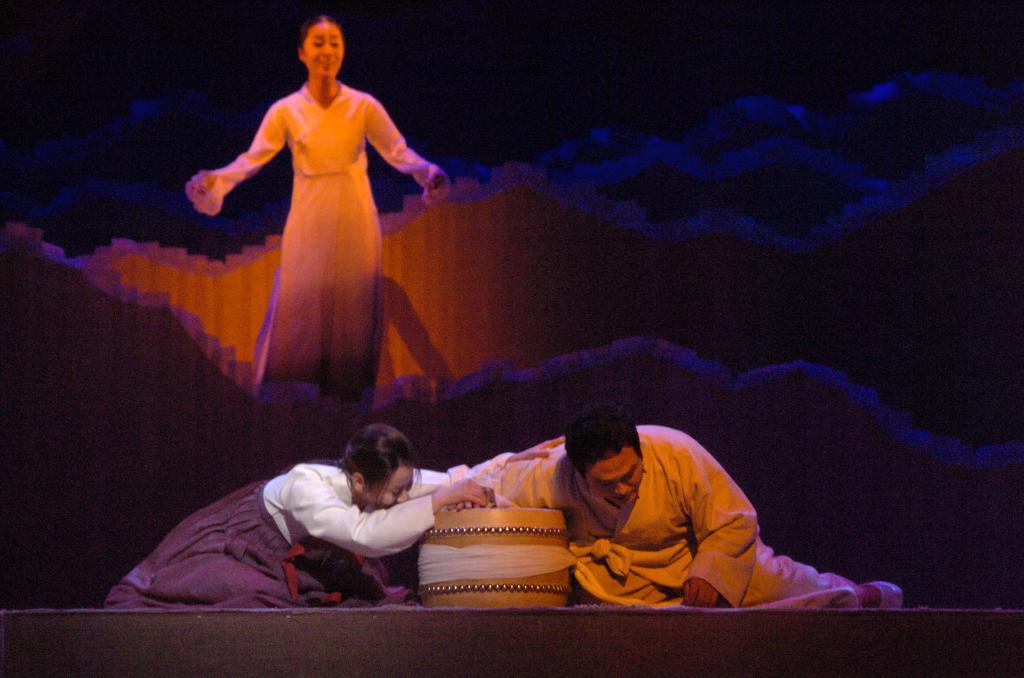Could you give a brief overview of what you see in this image? In this image I can see two people with different color dresses. I can see the cream color object in-between these people. In the back there is a person standing. And I can see few walls in the back. 